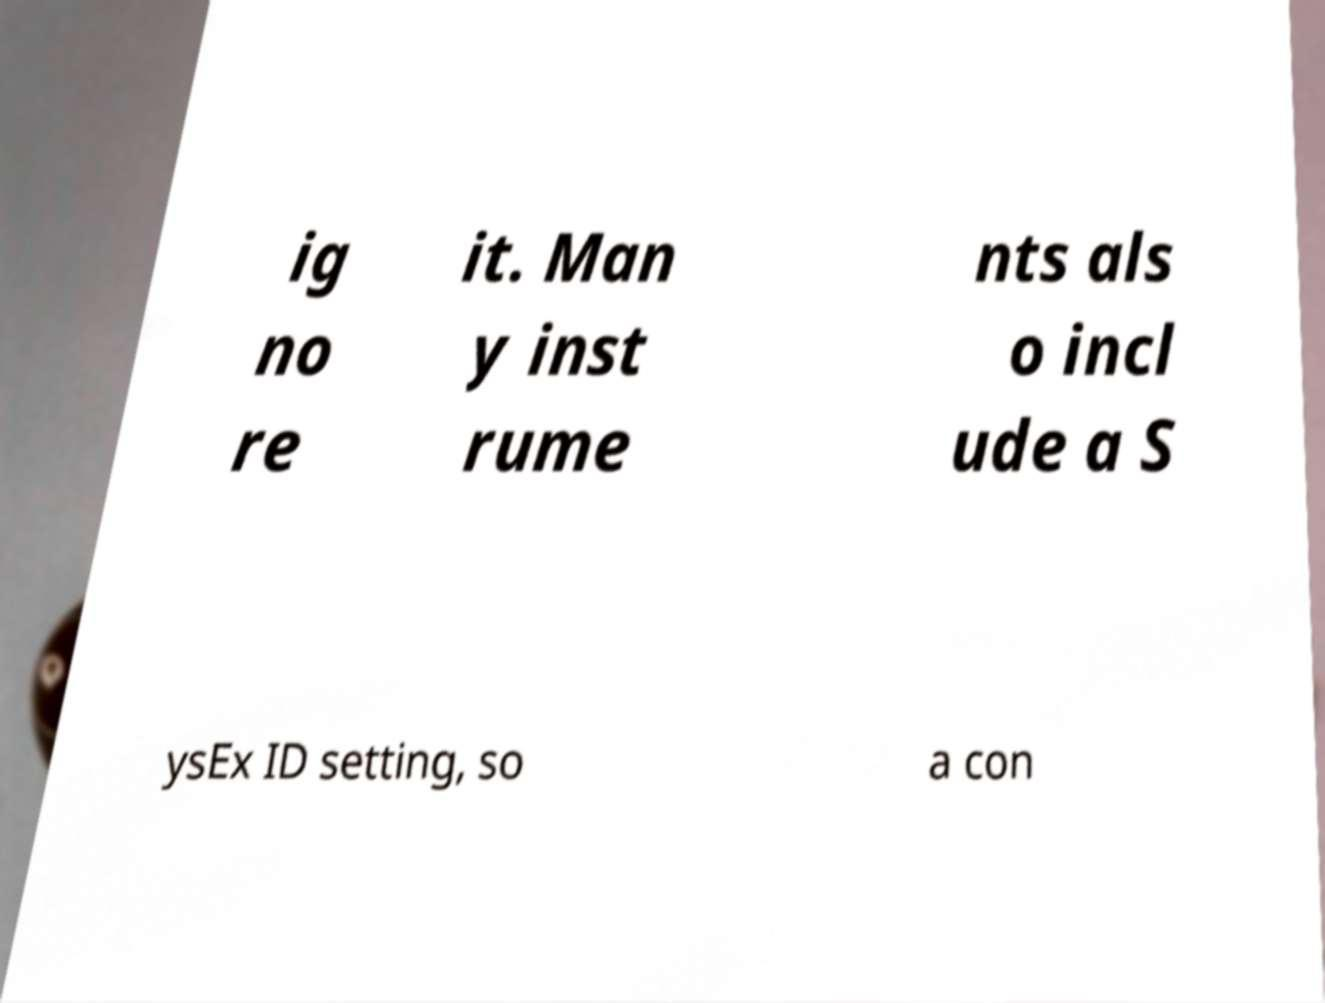I need the written content from this picture converted into text. Can you do that? ig no re it. Man y inst rume nts als o incl ude a S ysEx ID setting, so a con 